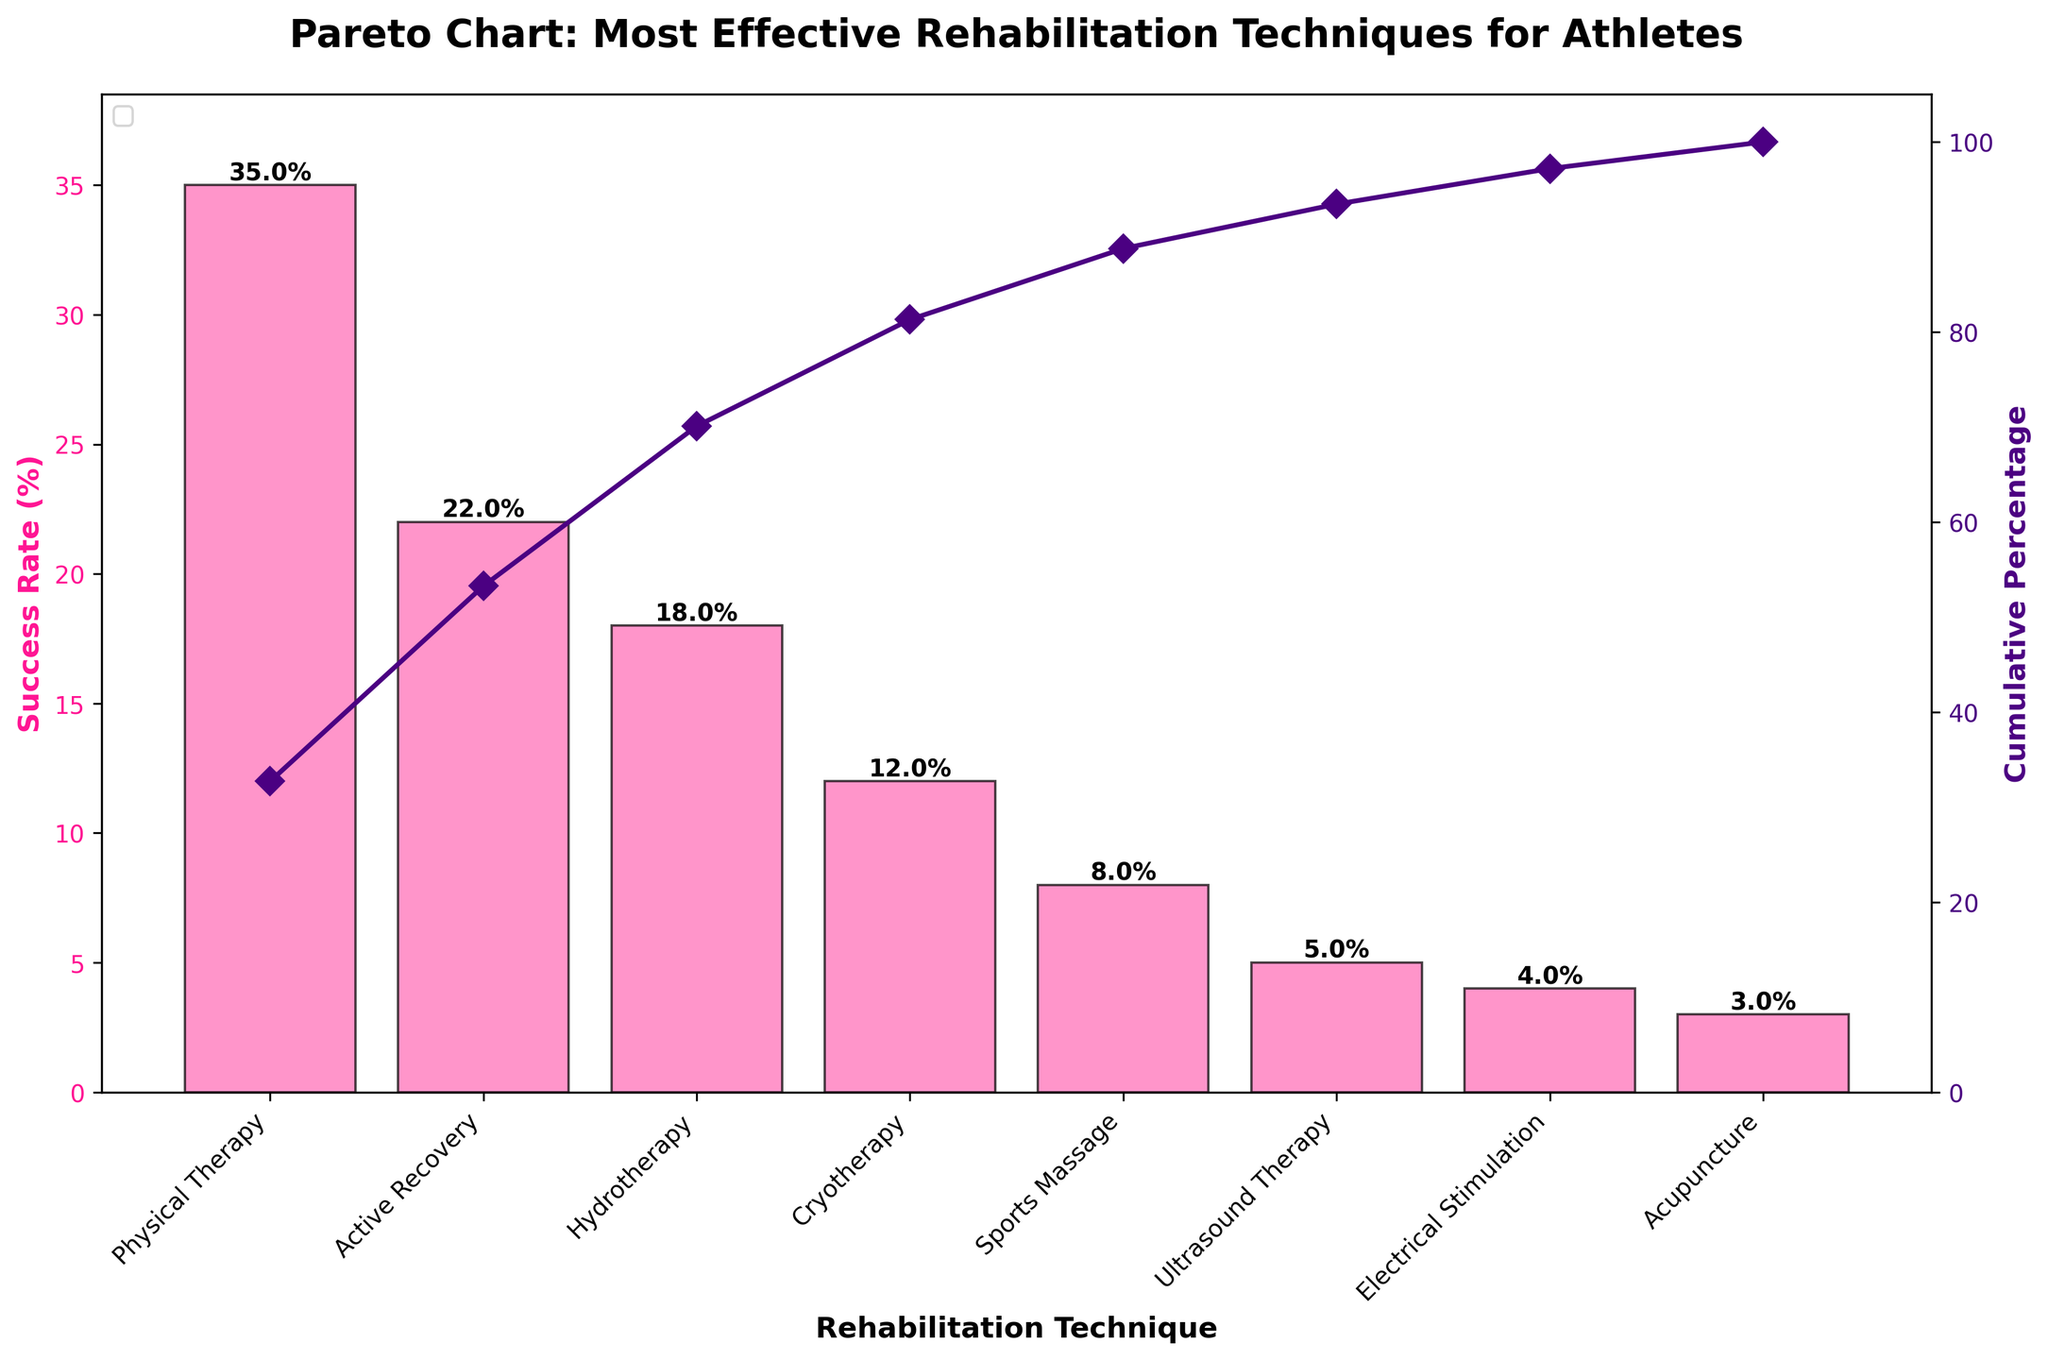What is the title of the chart? The title is written at the top of the chart in a large, bold font.
Answer: Pareto Chart: Most Effective Rehabilitation Techniques for Athletes What is the success rate of Hydrotherapy? The success rate is displayed on the top of the Hydrotherapy bar in the chart.
Answer: 18% Which rehabilitation technique has the highest success rate? By looking at the height of the bars, the tallest bar represents the highest success rate.
Answer: Physical Therapy What is the cumulative percentage for Cryotherapy? The cumulative percentage line intersects with the Cryotherapy bar; its value is shown on the secondary y-axis.
Answer: Approximately 87% Which technique shows a success rate just below Active Recovery? By comparing the bars, the technique with the next highest bar below Active Recovery can be identified.
Answer: Hydrotherapy What are the success rates for the top three techniques? The top three bars in descending order of height indicate their success rates.
Answer: 35%, 22%, 18% How do the success rates of Physical Therapy and Sports Massage compare? Compare the heights of the Physical Therapy and Sports Massage bars.
Answer: Physical Therapy is 35%, Sports Massage is 8%, so Physical Therapy is significantly higher What is the difference in success rate between Ultrasound Therapy and Electrical Stimulation? Calculate the numerical difference between the heights of the two bars.
Answer: 5% - 4% = 1% Which rehabilitation techniques have a success rate lower than 10%? Identify the bars whose heights are below the 10% mark on the primary y-axis.
Answer: Sports Massage, Ultrasound Therapy, Electrical Stimulation, Acupuncture What is the median value of the success rates? Arrange the success rates in ascending order and find the middle value or average the two middle values if there is an even number of data points.
Answer: (8+12) / 2 = 10% 